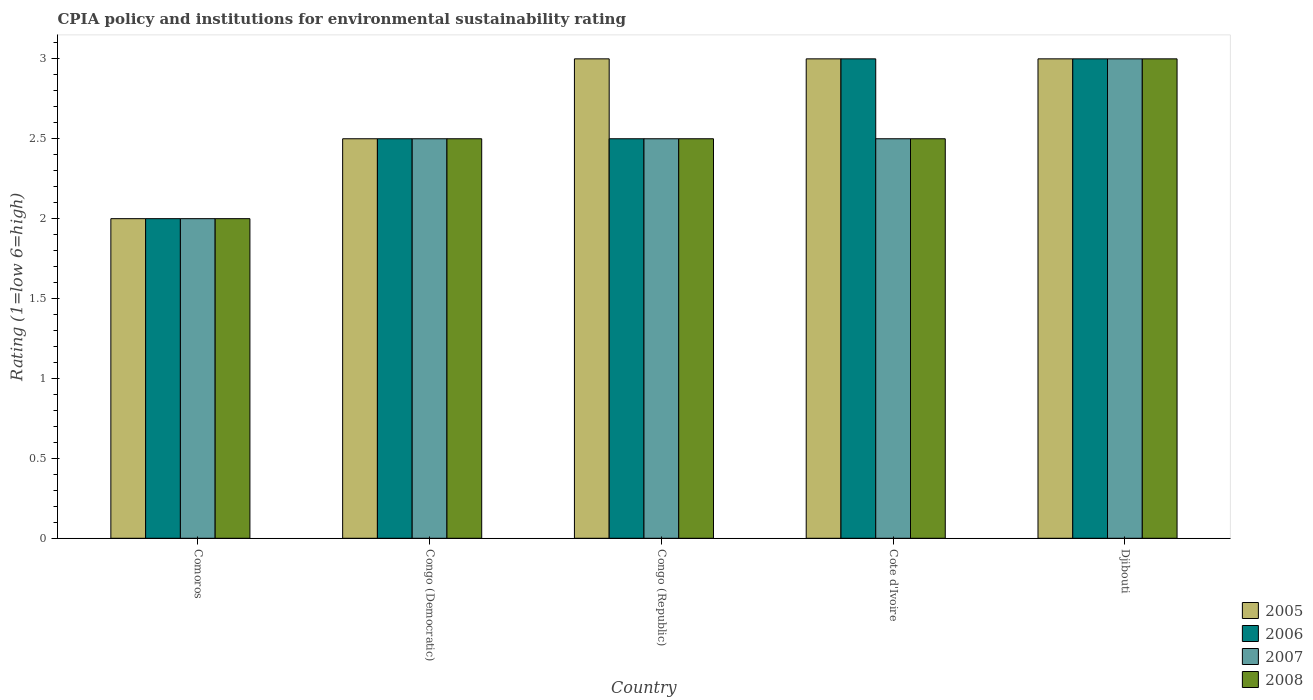How many different coloured bars are there?
Provide a succinct answer. 4. How many groups of bars are there?
Offer a terse response. 5. Are the number of bars on each tick of the X-axis equal?
Your answer should be very brief. Yes. What is the label of the 4th group of bars from the left?
Keep it short and to the point. Cote d'Ivoire. Across all countries, what is the maximum CPIA rating in 2005?
Your response must be concise. 3. In which country was the CPIA rating in 2005 maximum?
Your answer should be compact. Congo (Republic). In which country was the CPIA rating in 2006 minimum?
Ensure brevity in your answer.  Comoros. What is the total CPIA rating in 2008 in the graph?
Give a very brief answer. 12.5. What is the difference between the CPIA rating in 2007 in Comoros and that in Congo (Democratic)?
Offer a terse response. -0.5. What is the difference between the CPIA rating in 2005 in Djibouti and the CPIA rating in 2007 in Congo (Republic)?
Offer a very short reply. 0.5. What is the average CPIA rating in 2008 per country?
Your answer should be compact. 2.5. What is the difference between the CPIA rating of/in 2008 and CPIA rating of/in 2006 in Cote d'Ivoire?
Offer a very short reply. -0.5. In how many countries, is the CPIA rating in 2005 greater than 2.2?
Make the answer very short. 4. Is the CPIA rating in 2007 in Congo (Democratic) less than that in Djibouti?
Offer a terse response. Yes. What is the difference between the highest and the second highest CPIA rating in 2008?
Your answer should be compact. -0.5. Is the sum of the CPIA rating in 2006 in Congo (Democratic) and Cote d'Ivoire greater than the maximum CPIA rating in 2008 across all countries?
Provide a succinct answer. Yes. Is it the case that in every country, the sum of the CPIA rating in 2008 and CPIA rating in 2005 is greater than the sum of CPIA rating in 2006 and CPIA rating in 2007?
Your answer should be very brief. No. What does the 3rd bar from the right in Congo (Democratic) represents?
Your response must be concise. 2006. Is it the case that in every country, the sum of the CPIA rating in 2005 and CPIA rating in 2007 is greater than the CPIA rating in 2006?
Offer a very short reply. Yes. How many bars are there?
Ensure brevity in your answer.  20. Are all the bars in the graph horizontal?
Offer a terse response. No. What is the difference between two consecutive major ticks on the Y-axis?
Provide a short and direct response. 0.5. Are the values on the major ticks of Y-axis written in scientific E-notation?
Provide a short and direct response. No. Does the graph contain any zero values?
Provide a succinct answer. No. Where does the legend appear in the graph?
Provide a short and direct response. Bottom right. What is the title of the graph?
Your answer should be very brief. CPIA policy and institutions for environmental sustainability rating. Does "1997" appear as one of the legend labels in the graph?
Make the answer very short. No. What is the label or title of the X-axis?
Ensure brevity in your answer.  Country. What is the label or title of the Y-axis?
Your answer should be very brief. Rating (1=low 6=high). What is the Rating (1=low 6=high) in 2007 in Comoros?
Offer a very short reply. 2. What is the Rating (1=low 6=high) of 2008 in Comoros?
Your response must be concise. 2. What is the Rating (1=low 6=high) in 2005 in Congo (Democratic)?
Keep it short and to the point. 2.5. What is the Rating (1=low 6=high) in 2007 in Congo (Democratic)?
Your answer should be compact. 2.5. What is the Rating (1=low 6=high) in 2008 in Congo (Democratic)?
Offer a terse response. 2.5. What is the Rating (1=low 6=high) of 2006 in Congo (Republic)?
Make the answer very short. 2.5. What is the Rating (1=low 6=high) of 2007 in Congo (Republic)?
Offer a very short reply. 2.5. What is the Rating (1=low 6=high) in 2007 in Cote d'Ivoire?
Offer a very short reply. 2.5. What is the Rating (1=low 6=high) of 2008 in Cote d'Ivoire?
Provide a short and direct response. 2.5. What is the Rating (1=low 6=high) of 2005 in Djibouti?
Your response must be concise. 3. What is the Rating (1=low 6=high) in 2006 in Djibouti?
Provide a short and direct response. 3. What is the Rating (1=low 6=high) of 2007 in Djibouti?
Your answer should be compact. 3. Across all countries, what is the maximum Rating (1=low 6=high) of 2005?
Make the answer very short. 3. Across all countries, what is the maximum Rating (1=low 6=high) in 2006?
Your answer should be compact. 3. Across all countries, what is the maximum Rating (1=low 6=high) of 2007?
Your answer should be compact. 3. Across all countries, what is the maximum Rating (1=low 6=high) in 2008?
Provide a short and direct response. 3. Across all countries, what is the minimum Rating (1=low 6=high) in 2006?
Your response must be concise. 2. Across all countries, what is the minimum Rating (1=low 6=high) of 2008?
Provide a succinct answer. 2. What is the total Rating (1=low 6=high) in 2005 in the graph?
Your answer should be very brief. 13.5. What is the total Rating (1=low 6=high) in 2007 in the graph?
Ensure brevity in your answer.  12.5. What is the total Rating (1=low 6=high) in 2008 in the graph?
Your answer should be very brief. 12.5. What is the difference between the Rating (1=low 6=high) of 2005 in Comoros and that in Congo (Democratic)?
Keep it short and to the point. -0.5. What is the difference between the Rating (1=low 6=high) of 2006 in Comoros and that in Congo (Democratic)?
Provide a succinct answer. -0.5. What is the difference between the Rating (1=low 6=high) of 2007 in Comoros and that in Congo (Democratic)?
Ensure brevity in your answer.  -0.5. What is the difference between the Rating (1=low 6=high) of 2007 in Comoros and that in Congo (Republic)?
Your response must be concise. -0.5. What is the difference between the Rating (1=low 6=high) of 2006 in Comoros and that in Cote d'Ivoire?
Make the answer very short. -1. What is the difference between the Rating (1=low 6=high) in 2008 in Comoros and that in Cote d'Ivoire?
Offer a terse response. -0.5. What is the difference between the Rating (1=low 6=high) of 2006 in Congo (Democratic) and that in Congo (Republic)?
Offer a very short reply. 0. What is the difference between the Rating (1=low 6=high) of 2008 in Congo (Democratic) and that in Congo (Republic)?
Provide a succinct answer. 0. What is the difference between the Rating (1=low 6=high) of 2006 in Congo (Democratic) and that in Cote d'Ivoire?
Your answer should be very brief. -0.5. What is the difference between the Rating (1=low 6=high) of 2005 in Congo (Democratic) and that in Djibouti?
Your answer should be very brief. -0.5. What is the difference between the Rating (1=low 6=high) in 2006 in Congo (Democratic) and that in Djibouti?
Your answer should be very brief. -0.5. What is the difference between the Rating (1=low 6=high) of 2007 in Congo (Democratic) and that in Djibouti?
Your response must be concise. -0.5. What is the difference between the Rating (1=low 6=high) in 2006 in Congo (Republic) and that in Cote d'Ivoire?
Keep it short and to the point. -0.5. What is the difference between the Rating (1=low 6=high) of 2007 in Congo (Republic) and that in Cote d'Ivoire?
Offer a terse response. 0. What is the difference between the Rating (1=low 6=high) of 2005 in Congo (Republic) and that in Djibouti?
Provide a short and direct response. 0. What is the difference between the Rating (1=low 6=high) of 2006 in Congo (Republic) and that in Djibouti?
Keep it short and to the point. -0.5. What is the difference between the Rating (1=low 6=high) in 2007 in Congo (Republic) and that in Djibouti?
Offer a very short reply. -0.5. What is the difference between the Rating (1=low 6=high) of 2008 in Congo (Republic) and that in Djibouti?
Your answer should be compact. -0.5. What is the difference between the Rating (1=low 6=high) in 2005 in Cote d'Ivoire and that in Djibouti?
Keep it short and to the point. 0. What is the difference between the Rating (1=low 6=high) in 2006 in Cote d'Ivoire and that in Djibouti?
Offer a very short reply. 0. What is the difference between the Rating (1=low 6=high) in 2008 in Cote d'Ivoire and that in Djibouti?
Your response must be concise. -0.5. What is the difference between the Rating (1=low 6=high) in 2005 in Comoros and the Rating (1=low 6=high) in 2007 in Congo (Democratic)?
Your response must be concise. -0.5. What is the difference between the Rating (1=low 6=high) of 2006 in Comoros and the Rating (1=low 6=high) of 2007 in Congo (Democratic)?
Your response must be concise. -0.5. What is the difference between the Rating (1=low 6=high) of 2006 in Comoros and the Rating (1=low 6=high) of 2008 in Congo (Democratic)?
Give a very brief answer. -0.5. What is the difference between the Rating (1=low 6=high) of 2007 in Comoros and the Rating (1=low 6=high) of 2008 in Congo (Democratic)?
Your answer should be compact. -0.5. What is the difference between the Rating (1=low 6=high) in 2005 in Comoros and the Rating (1=low 6=high) in 2006 in Congo (Republic)?
Provide a succinct answer. -0.5. What is the difference between the Rating (1=low 6=high) in 2005 in Comoros and the Rating (1=low 6=high) in 2007 in Congo (Republic)?
Offer a very short reply. -0.5. What is the difference between the Rating (1=low 6=high) of 2005 in Comoros and the Rating (1=low 6=high) of 2008 in Congo (Republic)?
Offer a terse response. -0.5. What is the difference between the Rating (1=low 6=high) of 2006 in Comoros and the Rating (1=low 6=high) of 2007 in Congo (Republic)?
Keep it short and to the point. -0.5. What is the difference between the Rating (1=low 6=high) in 2006 in Comoros and the Rating (1=low 6=high) in 2008 in Congo (Republic)?
Your answer should be compact. -0.5. What is the difference between the Rating (1=low 6=high) of 2005 in Comoros and the Rating (1=low 6=high) of 2006 in Cote d'Ivoire?
Provide a succinct answer. -1. What is the difference between the Rating (1=low 6=high) of 2005 in Comoros and the Rating (1=low 6=high) of 2008 in Cote d'Ivoire?
Provide a short and direct response. -0.5. What is the difference between the Rating (1=low 6=high) in 2006 in Comoros and the Rating (1=low 6=high) in 2007 in Cote d'Ivoire?
Your answer should be very brief. -0.5. What is the difference between the Rating (1=low 6=high) of 2005 in Comoros and the Rating (1=low 6=high) of 2006 in Djibouti?
Keep it short and to the point. -1. What is the difference between the Rating (1=low 6=high) in 2006 in Comoros and the Rating (1=low 6=high) in 2008 in Djibouti?
Provide a succinct answer. -1. What is the difference between the Rating (1=low 6=high) of 2005 in Congo (Democratic) and the Rating (1=low 6=high) of 2006 in Congo (Republic)?
Offer a terse response. 0. What is the difference between the Rating (1=low 6=high) of 2006 in Congo (Democratic) and the Rating (1=low 6=high) of 2007 in Congo (Republic)?
Give a very brief answer. 0. What is the difference between the Rating (1=low 6=high) in 2007 in Congo (Democratic) and the Rating (1=low 6=high) in 2008 in Congo (Republic)?
Your response must be concise. 0. What is the difference between the Rating (1=low 6=high) in 2005 in Congo (Democratic) and the Rating (1=low 6=high) in 2007 in Cote d'Ivoire?
Ensure brevity in your answer.  0. What is the difference between the Rating (1=low 6=high) of 2005 in Congo (Democratic) and the Rating (1=low 6=high) of 2008 in Cote d'Ivoire?
Keep it short and to the point. 0. What is the difference between the Rating (1=low 6=high) of 2005 in Congo (Democratic) and the Rating (1=low 6=high) of 2006 in Djibouti?
Provide a succinct answer. -0.5. What is the difference between the Rating (1=low 6=high) in 2005 in Congo (Democratic) and the Rating (1=low 6=high) in 2007 in Djibouti?
Provide a succinct answer. -0.5. What is the difference between the Rating (1=low 6=high) in 2007 in Congo (Democratic) and the Rating (1=low 6=high) in 2008 in Djibouti?
Your response must be concise. -0.5. What is the difference between the Rating (1=low 6=high) of 2005 in Congo (Republic) and the Rating (1=low 6=high) of 2008 in Cote d'Ivoire?
Ensure brevity in your answer.  0.5. What is the difference between the Rating (1=low 6=high) of 2006 in Congo (Republic) and the Rating (1=low 6=high) of 2007 in Cote d'Ivoire?
Ensure brevity in your answer.  0. What is the difference between the Rating (1=low 6=high) in 2006 in Congo (Republic) and the Rating (1=low 6=high) in 2008 in Cote d'Ivoire?
Keep it short and to the point. 0. What is the difference between the Rating (1=low 6=high) in 2007 in Congo (Republic) and the Rating (1=low 6=high) in 2008 in Cote d'Ivoire?
Your answer should be compact. 0. What is the difference between the Rating (1=low 6=high) of 2005 in Congo (Republic) and the Rating (1=low 6=high) of 2006 in Djibouti?
Your response must be concise. 0. What is the difference between the Rating (1=low 6=high) in 2005 in Congo (Republic) and the Rating (1=low 6=high) in 2007 in Djibouti?
Offer a terse response. 0. What is the difference between the Rating (1=low 6=high) in 2006 in Congo (Republic) and the Rating (1=low 6=high) in 2007 in Djibouti?
Your response must be concise. -0.5. What is the difference between the Rating (1=low 6=high) in 2006 in Congo (Republic) and the Rating (1=low 6=high) in 2008 in Djibouti?
Provide a short and direct response. -0.5. What is the difference between the Rating (1=low 6=high) of 2007 in Congo (Republic) and the Rating (1=low 6=high) of 2008 in Djibouti?
Make the answer very short. -0.5. What is the difference between the Rating (1=low 6=high) of 2005 in Cote d'Ivoire and the Rating (1=low 6=high) of 2007 in Djibouti?
Make the answer very short. 0. What is the difference between the Rating (1=low 6=high) in 2006 in Cote d'Ivoire and the Rating (1=low 6=high) in 2007 in Djibouti?
Keep it short and to the point. 0. What is the average Rating (1=low 6=high) of 2005 per country?
Provide a succinct answer. 2.7. What is the average Rating (1=low 6=high) in 2007 per country?
Keep it short and to the point. 2.5. What is the average Rating (1=low 6=high) of 2008 per country?
Your answer should be very brief. 2.5. What is the difference between the Rating (1=low 6=high) in 2005 and Rating (1=low 6=high) in 2006 in Comoros?
Keep it short and to the point. 0. What is the difference between the Rating (1=low 6=high) in 2005 and Rating (1=low 6=high) in 2007 in Comoros?
Give a very brief answer. 0. What is the difference between the Rating (1=low 6=high) in 2005 and Rating (1=low 6=high) in 2008 in Comoros?
Offer a very short reply. 0. What is the difference between the Rating (1=low 6=high) of 2005 and Rating (1=low 6=high) of 2007 in Congo (Democratic)?
Your response must be concise. 0. What is the difference between the Rating (1=low 6=high) of 2005 and Rating (1=low 6=high) of 2006 in Congo (Republic)?
Your response must be concise. 0.5. What is the difference between the Rating (1=low 6=high) in 2005 and Rating (1=low 6=high) in 2007 in Congo (Republic)?
Ensure brevity in your answer.  0.5. What is the difference between the Rating (1=low 6=high) in 2006 and Rating (1=low 6=high) in 2007 in Congo (Republic)?
Offer a very short reply. 0. What is the difference between the Rating (1=low 6=high) of 2005 and Rating (1=low 6=high) of 2007 in Cote d'Ivoire?
Ensure brevity in your answer.  0.5. What is the difference between the Rating (1=low 6=high) of 2005 and Rating (1=low 6=high) of 2008 in Cote d'Ivoire?
Your response must be concise. 0.5. What is the difference between the Rating (1=low 6=high) in 2006 and Rating (1=low 6=high) in 2007 in Cote d'Ivoire?
Provide a succinct answer. 0.5. What is the difference between the Rating (1=low 6=high) in 2005 and Rating (1=low 6=high) in 2007 in Djibouti?
Your response must be concise. 0. What is the difference between the Rating (1=low 6=high) of 2005 and Rating (1=low 6=high) of 2008 in Djibouti?
Your answer should be compact. 0. What is the difference between the Rating (1=low 6=high) in 2006 and Rating (1=low 6=high) in 2007 in Djibouti?
Provide a succinct answer. 0. What is the difference between the Rating (1=low 6=high) in 2006 and Rating (1=low 6=high) in 2008 in Djibouti?
Give a very brief answer. 0. What is the ratio of the Rating (1=low 6=high) of 2005 in Comoros to that in Congo (Democratic)?
Your answer should be compact. 0.8. What is the ratio of the Rating (1=low 6=high) of 2008 in Comoros to that in Congo (Democratic)?
Provide a short and direct response. 0.8. What is the ratio of the Rating (1=low 6=high) in 2005 in Comoros to that in Congo (Republic)?
Keep it short and to the point. 0.67. What is the ratio of the Rating (1=low 6=high) of 2007 in Comoros to that in Congo (Republic)?
Ensure brevity in your answer.  0.8. What is the ratio of the Rating (1=low 6=high) of 2006 in Comoros to that in Cote d'Ivoire?
Ensure brevity in your answer.  0.67. What is the ratio of the Rating (1=low 6=high) of 2008 in Comoros to that in Cote d'Ivoire?
Provide a succinct answer. 0.8. What is the ratio of the Rating (1=low 6=high) in 2007 in Comoros to that in Djibouti?
Give a very brief answer. 0.67. What is the ratio of the Rating (1=low 6=high) of 2007 in Congo (Democratic) to that in Congo (Republic)?
Make the answer very short. 1. What is the ratio of the Rating (1=low 6=high) in 2005 in Congo (Democratic) to that in Cote d'Ivoire?
Your answer should be very brief. 0.83. What is the ratio of the Rating (1=low 6=high) in 2007 in Congo (Democratic) to that in Cote d'Ivoire?
Give a very brief answer. 1. What is the ratio of the Rating (1=low 6=high) in 2007 in Congo (Democratic) to that in Djibouti?
Offer a very short reply. 0.83. What is the ratio of the Rating (1=low 6=high) of 2008 in Congo (Democratic) to that in Djibouti?
Make the answer very short. 0.83. What is the ratio of the Rating (1=low 6=high) in 2005 in Congo (Republic) to that in Cote d'Ivoire?
Offer a very short reply. 1. What is the ratio of the Rating (1=low 6=high) of 2006 in Congo (Republic) to that in Cote d'Ivoire?
Give a very brief answer. 0.83. What is the ratio of the Rating (1=low 6=high) of 2005 in Congo (Republic) to that in Djibouti?
Ensure brevity in your answer.  1. What is the ratio of the Rating (1=low 6=high) in 2006 in Cote d'Ivoire to that in Djibouti?
Your response must be concise. 1. What is the ratio of the Rating (1=low 6=high) of 2008 in Cote d'Ivoire to that in Djibouti?
Your response must be concise. 0.83. What is the difference between the highest and the second highest Rating (1=low 6=high) in 2005?
Provide a succinct answer. 0. What is the difference between the highest and the second highest Rating (1=low 6=high) of 2006?
Your answer should be compact. 0. What is the difference between the highest and the second highest Rating (1=low 6=high) in 2007?
Your response must be concise. 0.5. What is the difference between the highest and the lowest Rating (1=low 6=high) in 2006?
Ensure brevity in your answer.  1. 